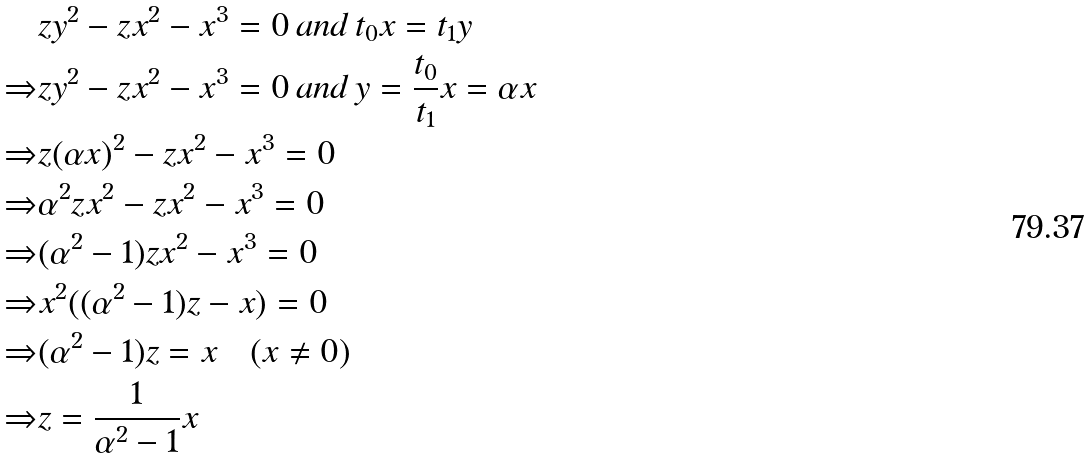Convert formula to latex. <formula><loc_0><loc_0><loc_500><loc_500>& z y ^ { 2 } - z x ^ { 2 } - x ^ { 3 } = 0 \, a n d \, t _ { 0 } x = t _ { 1 } y \\ \Rightarrow & z y ^ { 2 } - z x ^ { 2 } - x ^ { 3 } = 0 \, a n d \, y = \frac { t _ { 0 } } { t _ { 1 } } x = \alpha x \\ \Rightarrow & z ( \alpha x ) ^ { 2 } - z x ^ { 2 } - x ^ { 3 } = 0 \\ \Rightarrow & \alpha ^ { 2 } z x ^ { 2 } - z x ^ { 2 } - x ^ { 3 } = 0 \\ \Rightarrow & ( \alpha ^ { 2 } - 1 ) z x ^ { 2 } - x ^ { 3 } = 0 \\ \Rightarrow & x ^ { 2 } ( ( \alpha ^ { 2 } - 1 ) z - x ) = 0 \\ \Rightarrow & ( \alpha ^ { 2 } - 1 ) z = x \quad ( x \neq 0 ) \\ \Rightarrow & z = \frac { 1 } { \alpha ^ { 2 } - 1 } x</formula> 